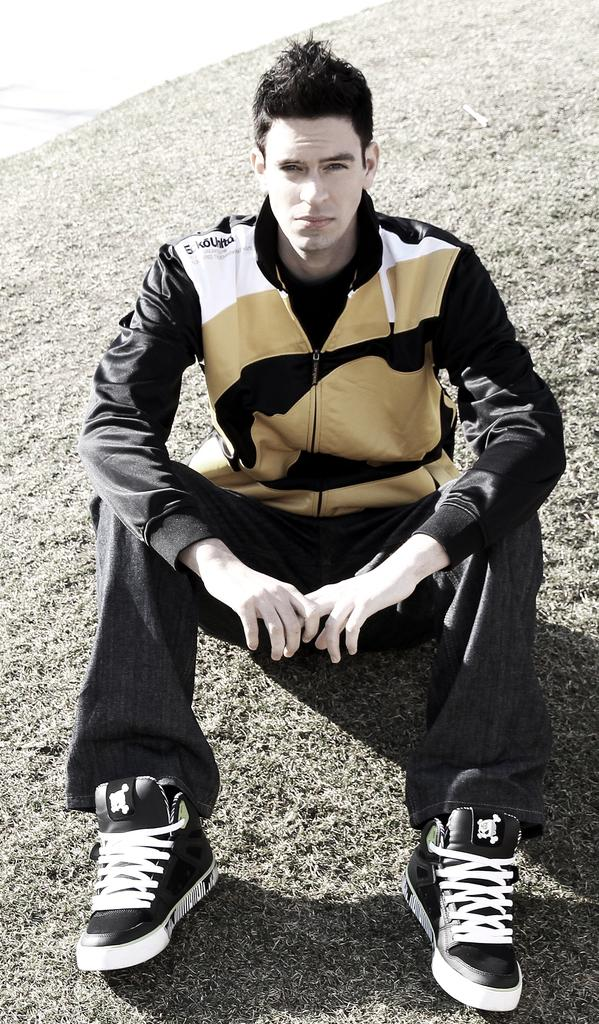Who is present in the image? There is a man in the image. What is the man doing in the image? The man is sitting on the grass. What type of clothing is the man wearing? The man is wearing a jacket and pants. What type of footwear is the man wearing? The man's shoes are visible in the image. What color is the ink on the daughter's drawing in the image? There is no daughter or drawing present in the image. What type of bed is visible in the image? There is no bed present in the image. 